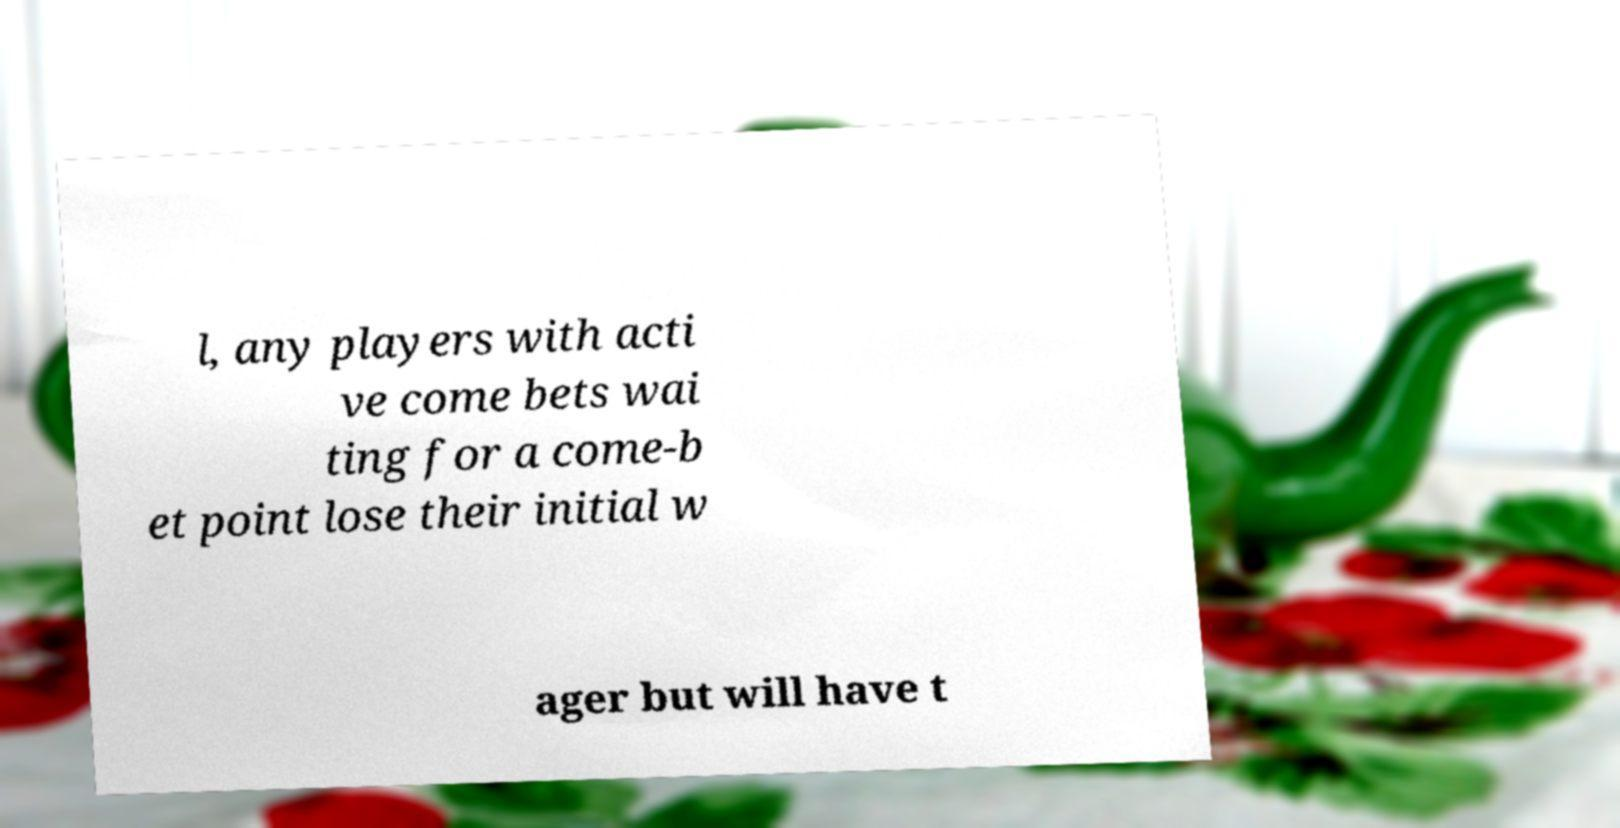There's text embedded in this image that I need extracted. Can you transcribe it verbatim? l, any players with acti ve come bets wai ting for a come-b et point lose their initial w ager but will have t 